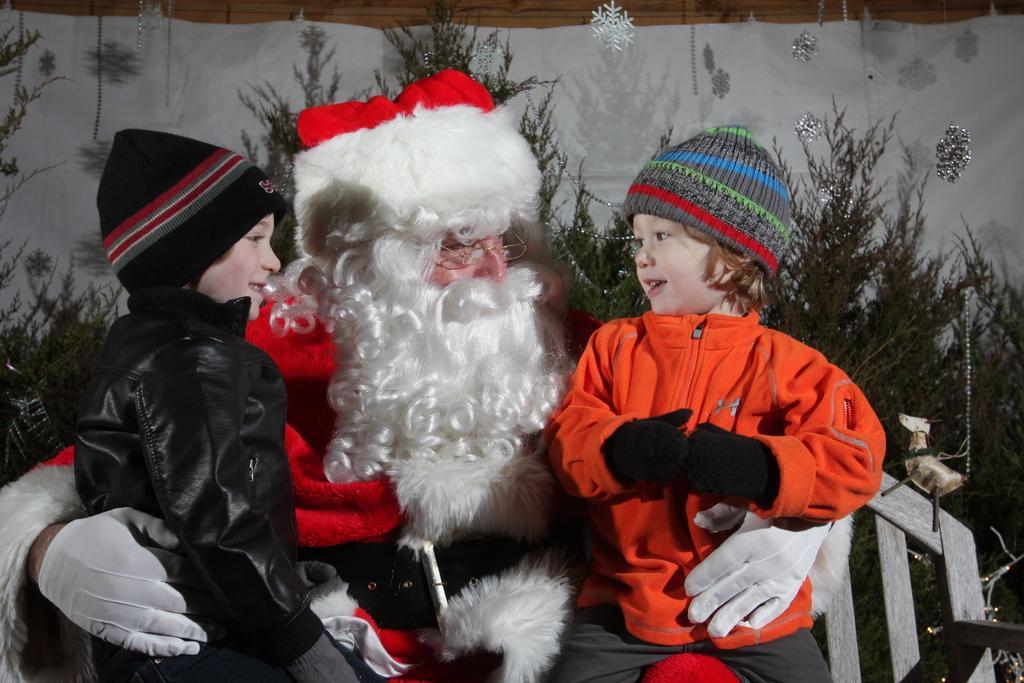Please provide a concise description of this image. In the center of the image we can see a person is sitting on the bench and he is holding two kids. And we can see they are in different costumes. In the background there is a wall, curtain, plants and decorative items. 